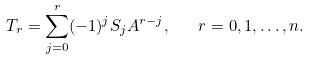Convert formula to latex. <formula><loc_0><loc_0><loc_500><loc_500>T _ { r } = \sum _ { j = 0 } ^ { r } ( - 1 ) ^ { j } S _ { j } A ^ { r - j } , \quad r = 0 , 1 , \dots , n .</formula> 